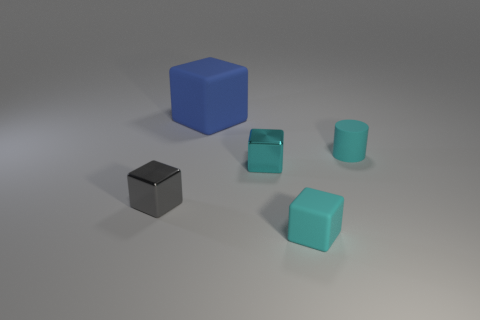Is there any other thing that has the same color as the large rubber block?
Provide a short and direct response. No. Do the big matte cube and the small matte cylinder have the same color?
Your answer should be compact. No. How many gray things are either balls or large cubes?
Give a very brief answer. 0. Are there fewer small cyan blocks in front of the big cube than small cubes?
Offer a terse response. Yes. What number of small cubes are on the left side of the matte thing in front of the cylinder?
Offer a very short reply. 2. How many other objects are the same size as the blue block?
Your answer should be very brief. 0. How many things are either rubber cubes or small metallic things that are on the left side of the blue thing?
Offer a very short reply. 3. Is the number of large red rubber balls less than the number of tiny blocks?
Your answer should be compact. Yes. What color is the small matte thing that is left of the cylinder that is behind the small cyan matte cube?
Provide a succinct answer. Cyan. There is another gray object that is the same shape as the big object; what is its material?
Your answer should be compact. Metal. 